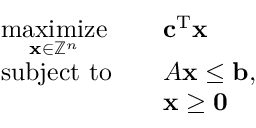Convert formula to latex. <formula><loc_0><loc_0><loc_500><loc_500>{ \begin{array} { r l r l } & { { \underset { x \in \mathbb { Z } ^ { n } } { \max i m i z e } } } & & { c ^ { T } x } \\ & { s u b j e c t t o } & & { A x \leq b , } \\ & & { x \geq 0 } \end{array} }</formula> 